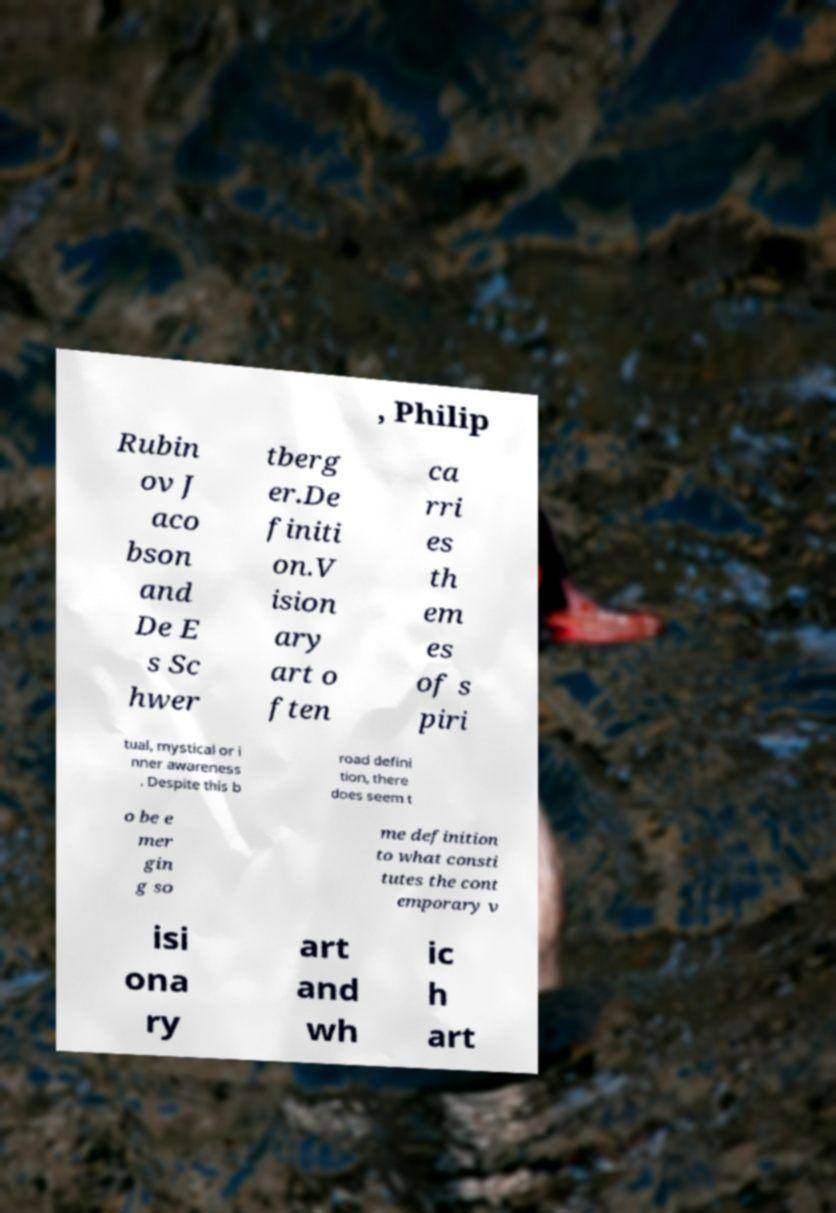Can you read and provide the text displayed in the image?This photo seems to have some interesting text. Can you extract and type it out for me? , Philip Rubin ov J aco bson and De E s Sc hwer tberg er.De finiti on.V ision ary art o ften ca rri es th em es of s piri tual, mystical or i nner awareness . Despite this b road defini tion, there does seem t o be e mer gin g so me definition to what consti tutes the cont emporary v isi ona ry art and wh ic h art 